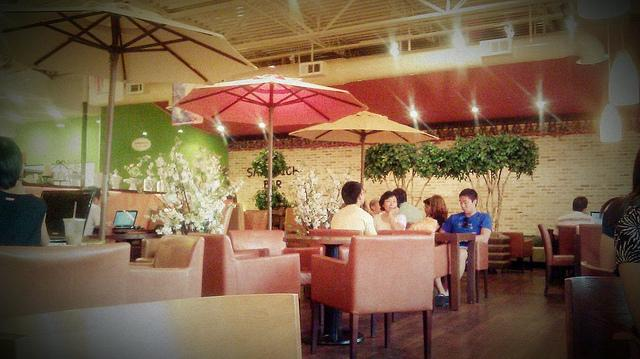What type of restaurant does this appear to be?

Choices:
A) asian
B) italian
C) english
D) greek asian 